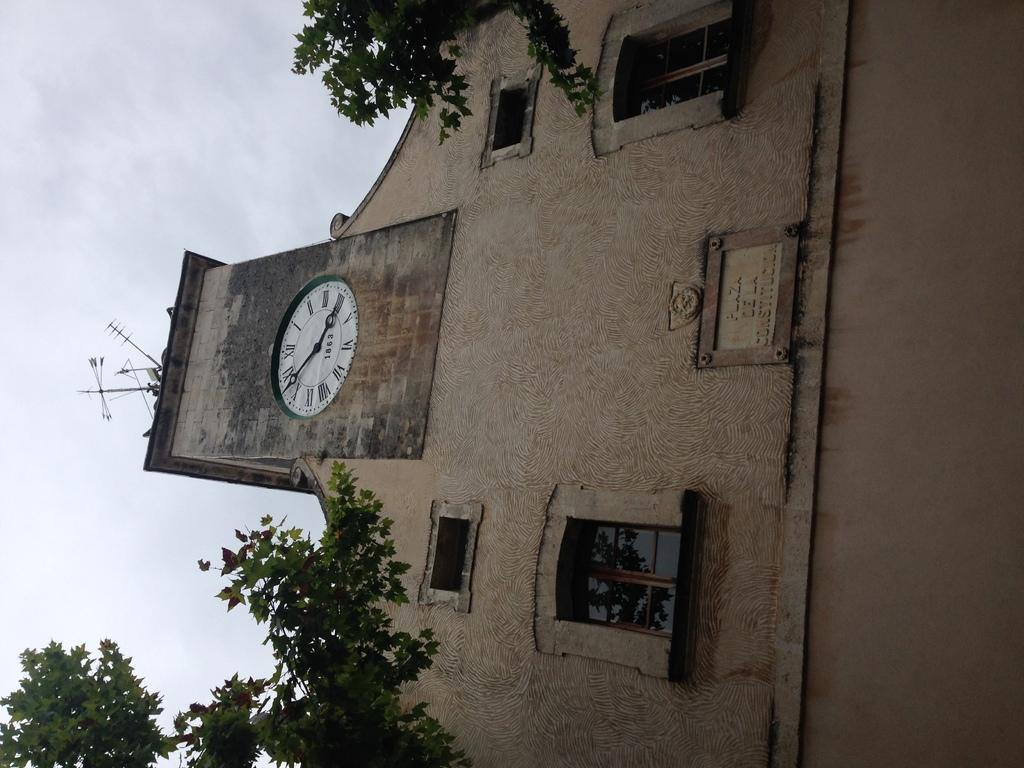What structure is the main subject of the image? There is a building in the image. What feature is attached to the wall of the building? A clock is attached to the wall of the building. What is unique about the clock in the image? The clock has windows. What type of vegetation is in front of the building? There are branches with leaves in front of the building. What part of the sky can be seen in the image? The sky is visible on the left side of the image. What color is the grape hanging from the clock in the image? There is no grape present in the image, and the clock does not have any hanging objects. 